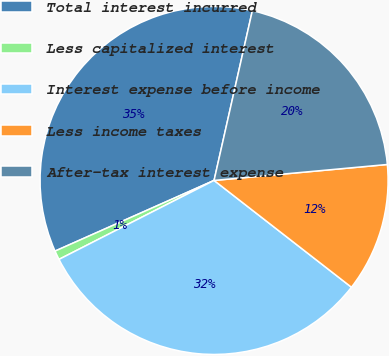Convert chart to OTSL. <chart><loc_0><loc_0><loc_500><loc_500><pie_chart><fcel>Total interest incurred<fcel>Less capitalized interest<fcel>Interest expense before income<fcel>Less income taxes<fcel>After-tax interest expense<nl><fcel>35.19%<fcel>0.84%<fcel>31.99%<fcel>11.98%<fcel>20.01%<nl></chart> 